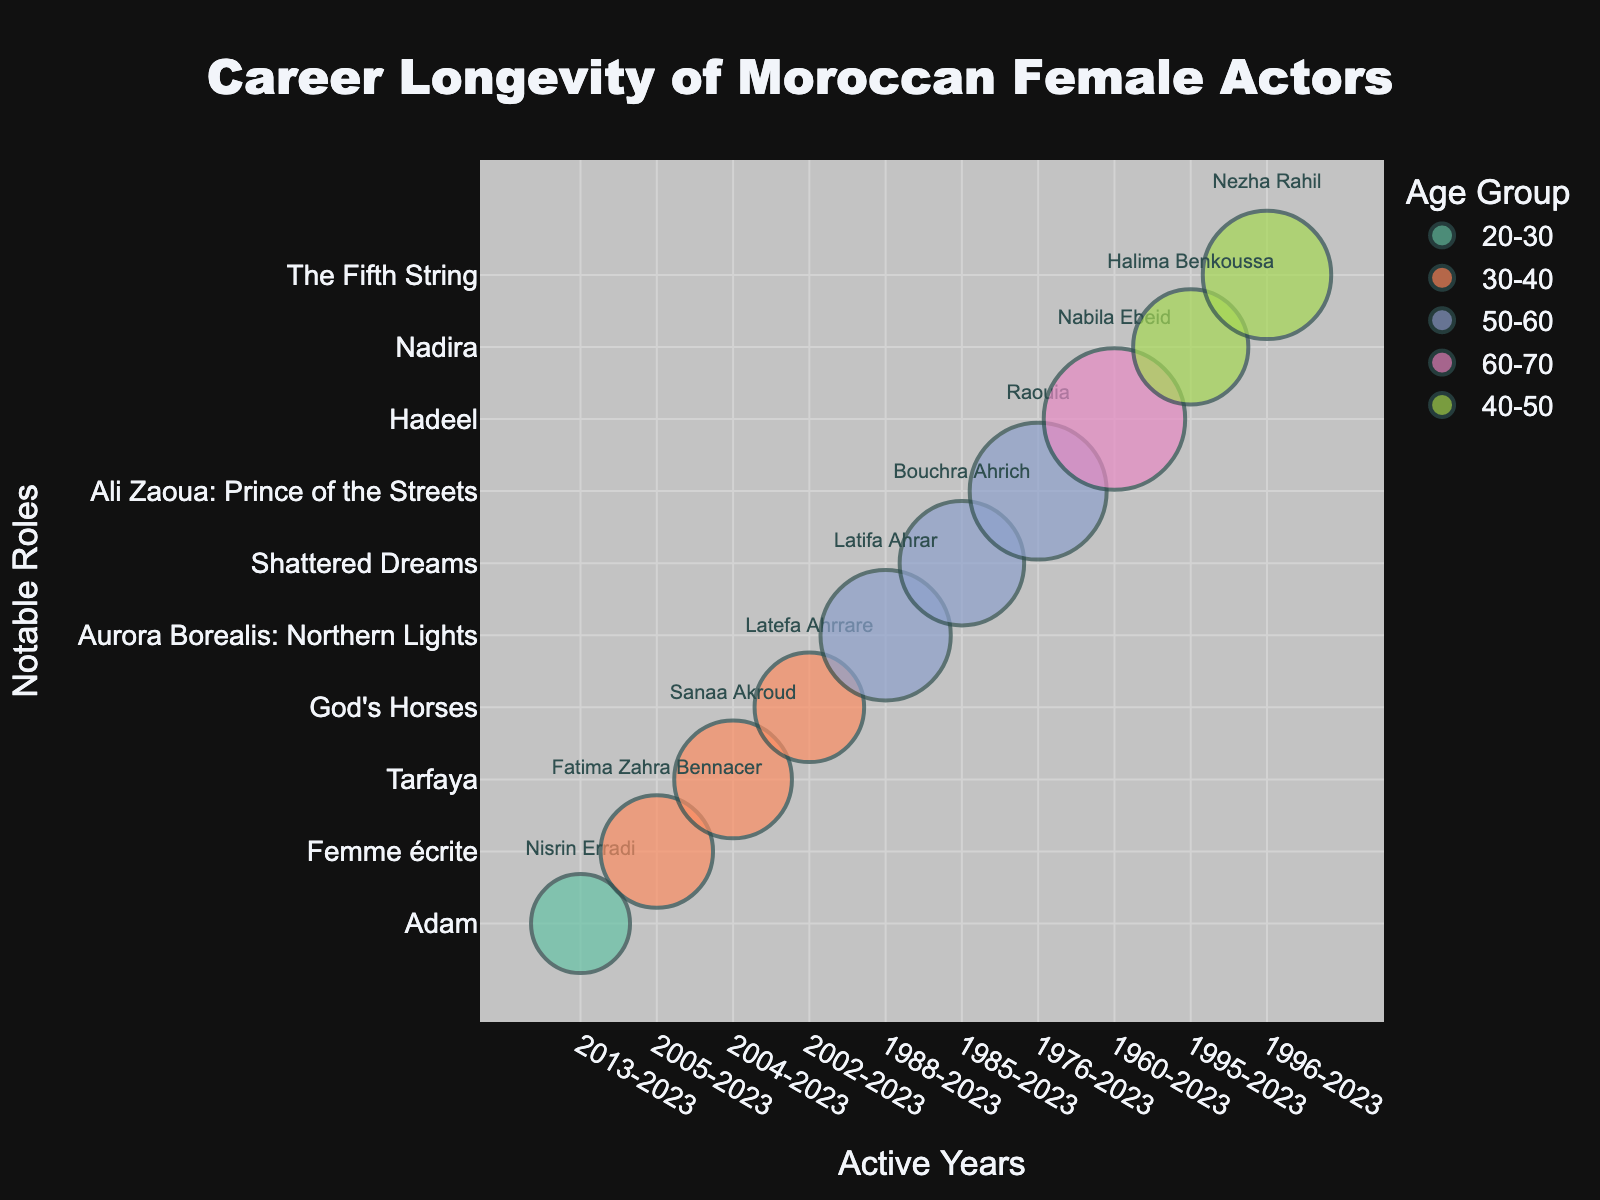What's the title of the chart? The title of the chart is always prominently displayed, usually at the top, to indicate the subject or focus of the chart.
Answer: Career Longevity of Moroccan Female Actors How many actors are in the age group 50-60? By visually scanning the chart and counting the bubbles colored for the age group 50-60 (using the legend for reference), we find the number of actors.
Answer: 3 Which actor has the longest active years? By looking at the x-axis representing active years, identify the actor whose bubble spans the longest distance across the timeline.
Answer: Nabila Ebeid What's the notable role of Nezha Rahil? By hovering over or finding the bubble labeled "Nezha Rahil" in the chart, we can read the information directly.
Answer: The Fifth String Which age group has the highest number of roles in total? Sum the number of roles for each actor within each age group, then compare the totals to find the highest. For example:
20-30: 6
30-40: 10 + 12 + 9 = 31
50-60: 18 + 15 + 22 = 55
60-70: 25
Answer: 50-60 Who has the most number of roles? By comparing the bubble sizes, which are proportional to the number of roles, identify the largest bubble.
Answer: Nabila Ebeid Which actor began their career earliest? By looking at the leftmost position on the x-axis (Active Years), identify which actor's bubble starts from the earliest year.
Answer: Nabila Ebeid How many roles has Latifa Ahrar acted in? Find the bubble representing Latifa Ahrar and read the number of roles, either from the size of the bubble or hover information.
Answer: 18 Who has notable roles in 'Adam'? By checking the y-axis values or hover information for notable roles, identify the actor listed for 'Adam'.
Answer: Nisrin Erradi What is the difference in the number of roles between Bouchra Ahrich and Sanaa Akroud? Subtract the number of roles: Bouchra Ahrich (15) - Sanaa Akroud (12).
Answer: 3 